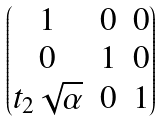Convert formula to latex. <formula><loc_0><loc_0><loc_500><loc_500>\begin{pmatrix} 1 & 0 & 0 \\ 0 & 1 & 0 \\ t _ { 2 } \sqrt { \alpha } & 0 & 1 \end{pmatrix}</formula> 